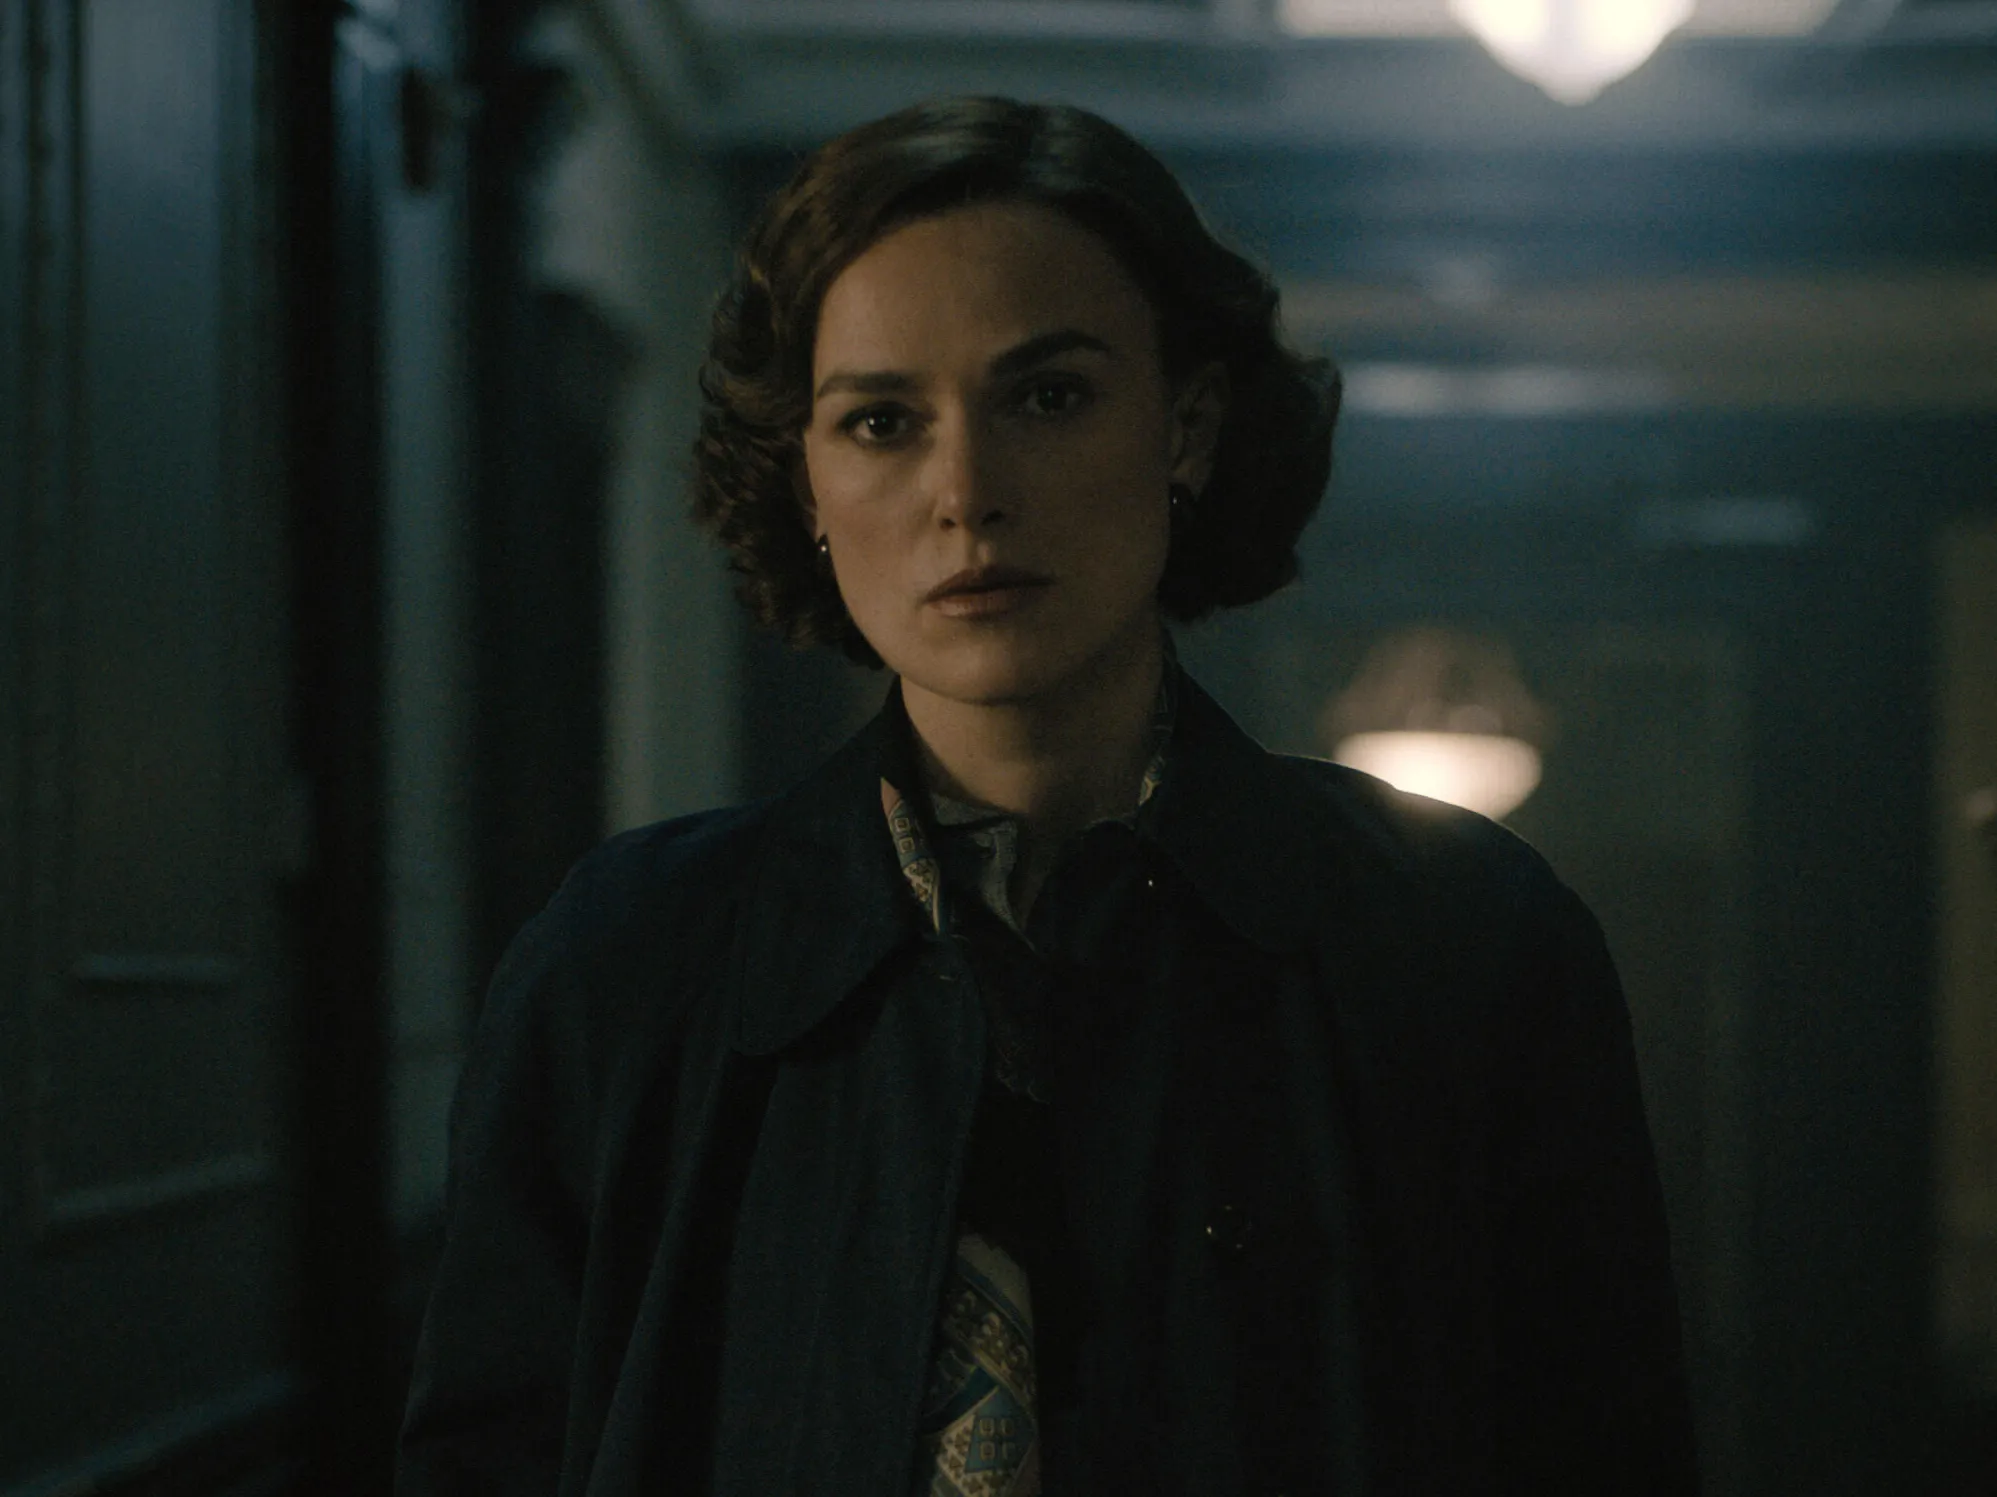Imagine a completely different and unusual scenario. What could be happening here? In an entirely different and imaginative context, let's reimagine this image in a fantastical world. The woman is actually a powerful sorceress on a secret mission to uncover an ancient relic hidden deep within a magical castle. The dimly lit hallway is enchanted, with portraits on the walls whispering secrets and the floor tiles shifting to reveal hidden traps. Her pensive expression stems from deciphering a complex riddle that guards the entrance to the relic's chamber. Each step forward requires unraveling spells and taming mythical creatures, demanding both her magical prowess and wit. 